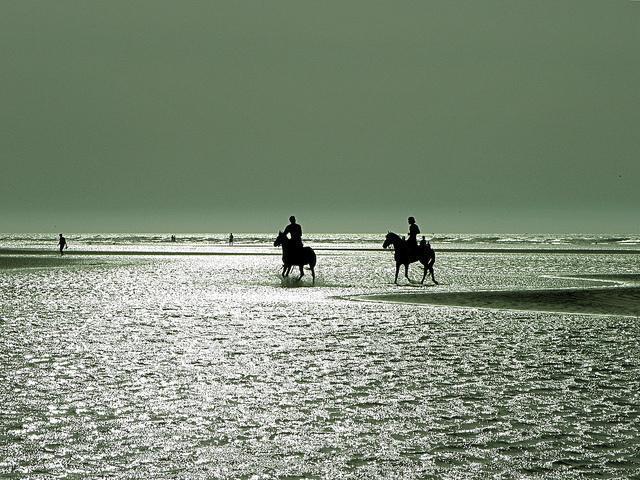How many clocks are there?
Give a very brief answer. 0. 